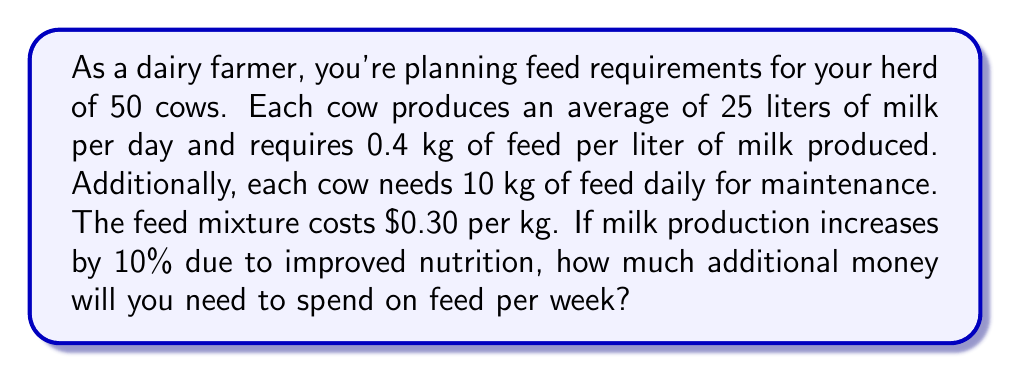Provide a solution to this math problem. Let's solve this problem step by step:

1. Calculate the current daily feed requirement per cow:
   - For milk production: $25 \text{ L} \times 0.4 \text{ kg/L} = 10 \text{ kg}$
   - For maintenance: $10 \text{ kg}$
   - Total: $10 \text{ kg} + 10 \text{ kg} = 20 \text{ kg}$ per cow per day

2. Calculate the current daily feed requirement for the entire herd:
   $20 \text{ kg} \times 50 \text{ cows} = 1000 \text{ kg}$ per day

3. Calculate the new milk production after 10% increase:
   $25 \text{ L} \times 1.10 = 27.5 \text{ L}$ per cow per day

4. Calculate the new daily feed requirement per cow:
   - For milk production: $27.5 \text{ L} \times 0.4 \text{ kg/L} = 11 \text{ kg}$
   - For maintenance: $10 \text{ kg}$
   - Total: $11 \text{ kg} + 10 \text{ kg} = 21 \text{ kg}$ per cow per day

5. Calculate the new daily feed requirement for the entire herd:
   $21 \text{ kg} \times 50 \text{ cows} = 1050 \text{ kg}$ per day

6. Calculate the additional daily feed requirement:
   $1050 \text{ kg} - 1000 \text{ kg} = 50 \text{ kg}$ per day

7. Calculate the additional weekly feed requirement:
   $50 \text{ kg} \times 7 \text{ days} = 350 \text{ kg}$ per week

8. Calculate the additional cost per week:
   $350 \text{ kg} \times \$0.30/\text{kg} = \$105$ per week

Therefore, you will need to spend an additional $105 per week on feed.
Answer: $105 per week 